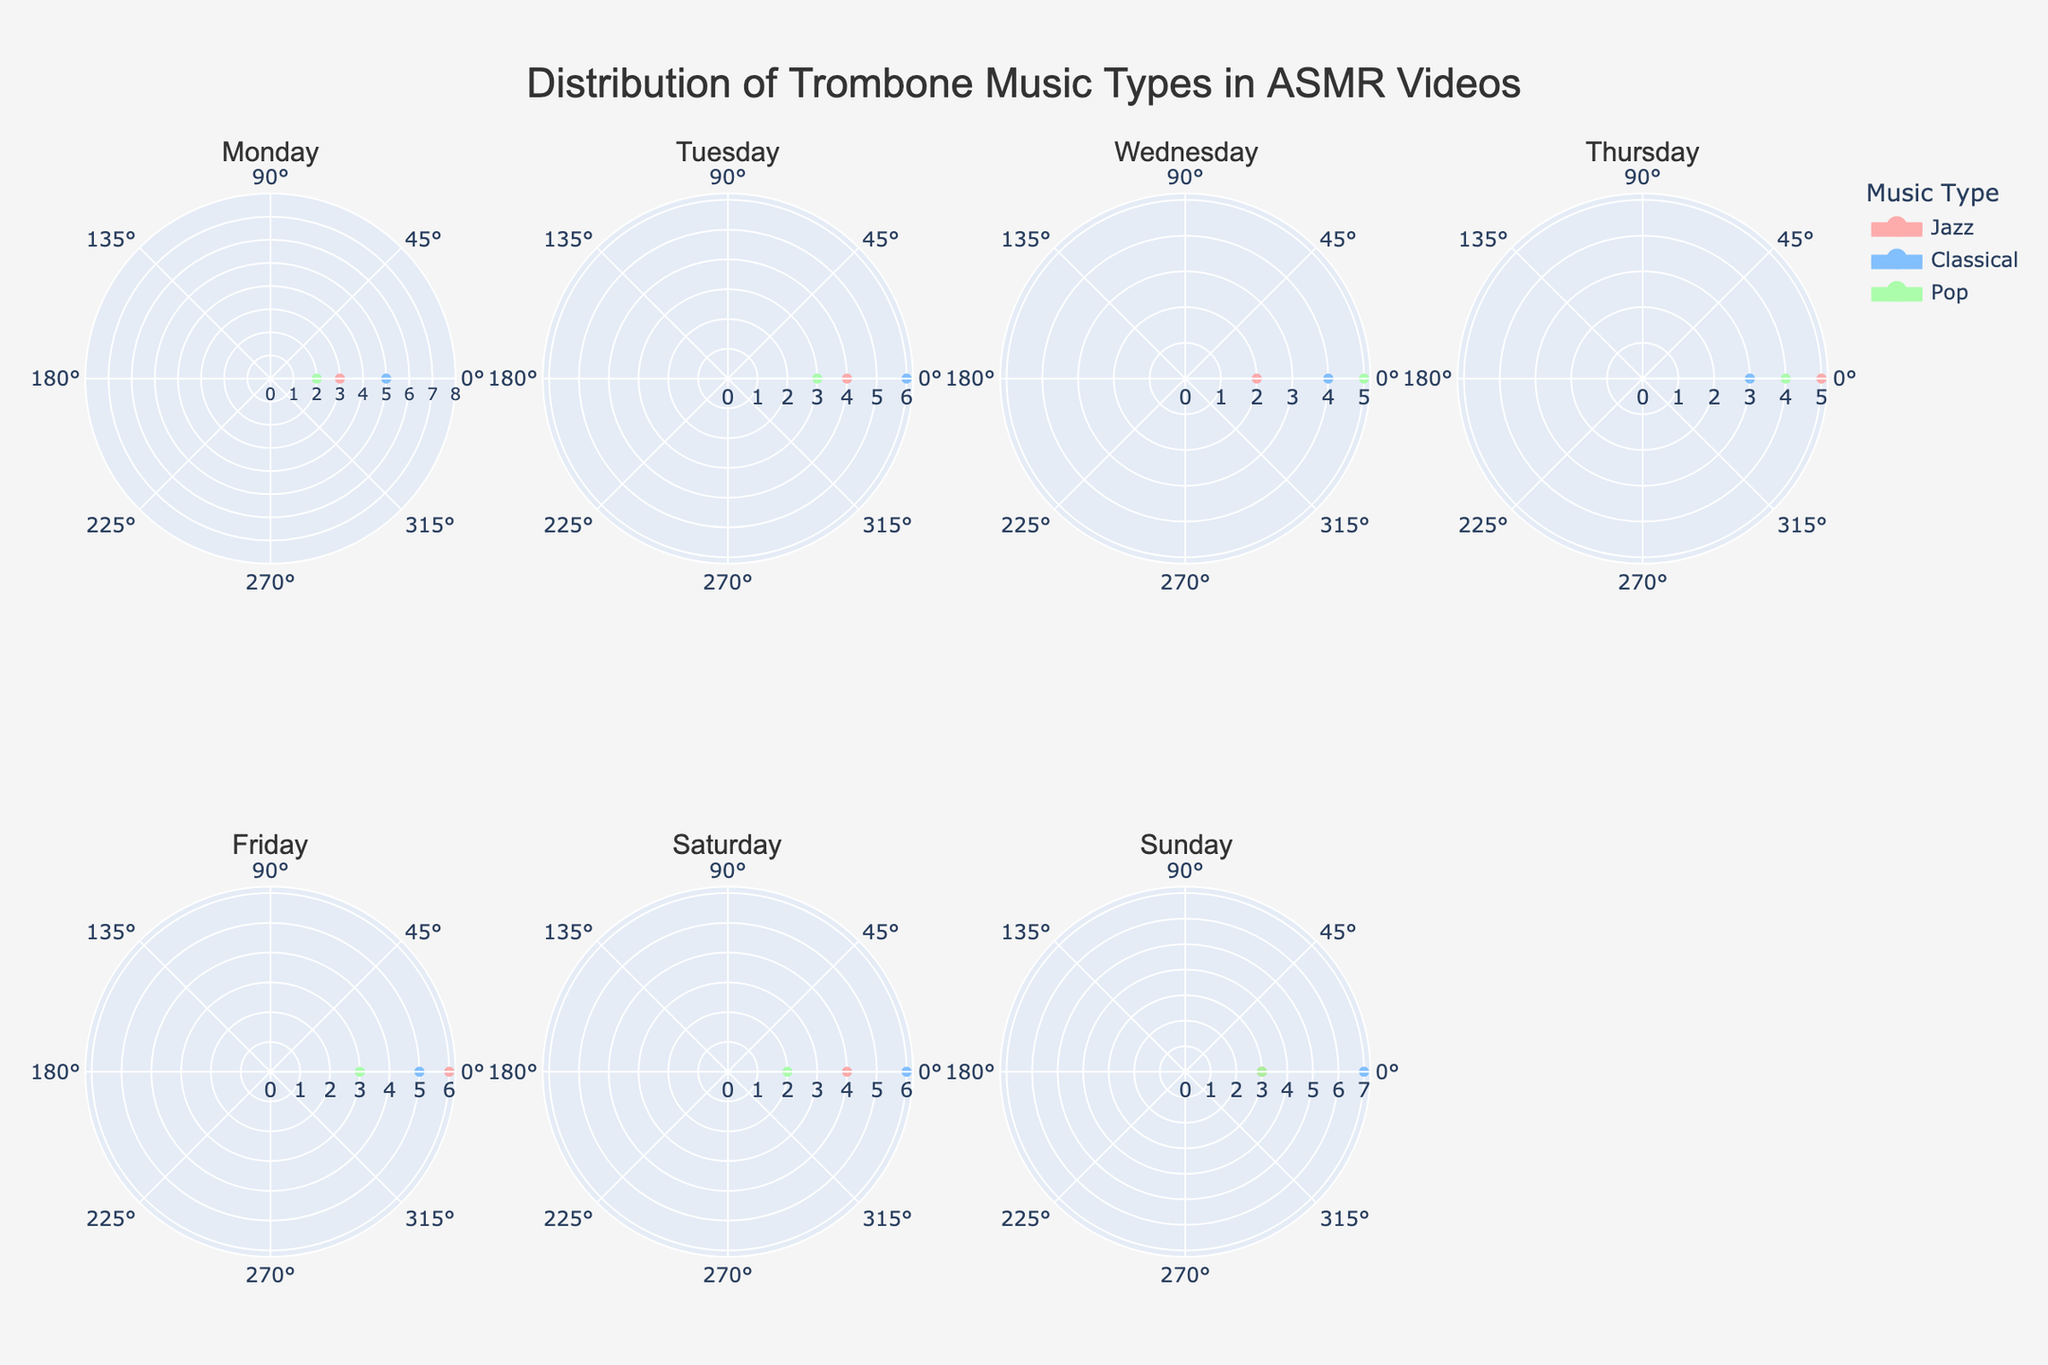How many music types are featured in ASMR videos on Wednesday? The rose charts for each day are organized by subplot titles, with music types displayed in different colors. For Wednesday, the subplot shows three colors representing Jazz, Classical, and Pop.
Answer: 3 On which day is Classical music most featured in ASMR videos? To find the day with the highest count for Classical music, look for the day when the count peaks among subplots. On Sunday, Classical music reaches a peak of 7.
Answer: Sunday What is the total count of Pop music in the whole week? Add the counts of Pop music from each day: 2 (Mon) + 3 (Tue) + 5 (Wed) + 4 (Thu) + 3 (Fri) + 2 (Sat) + 3 (Sun) = 22.
Answer: 22 Which day has the least variation in the count of different music types? Least variation means the counts for all music types are close to each other. On Thursday, the counts are 5 (Jazz), 3 (Classical), and 4 (Pop), showing small variation.
Answer: Thursday How many ASMR videos feature Jazz music on Friday? Refer to the Friday subplot and identify the count for Jazz music, which is represented by the relevant color. The count is 6.
Answer: 6 How does the distribution of Classical music on Tuesday compare to Saturday? Compare the counts: Tuesday has 6 for Classical music, while Saturday also has 6. They have the same count.
Answer: Equal/Same What is the average count of Jazz music throughout the week? Sum the Jazz counts for each day and divide by 7 (days): (3 + 4 + 2 + 5 + 6 + 4 + 3) / 7 = 27 / 7 ≈ 3.86.
Answer: 3.86 Is there a day where Pop music is more common than Classical music? Compare the counts for Classical and Pop for each day. On Wednesday, Pop (5) is more than Classical (4).
Answer: Wednesday Which day has the most uniform distribution of all three music types? Uniform distribution means all three types have similar counts. On Tuesday, the counts are 4 (Jazz), 6 (Classical), and 3 (Pop), which are relatively close compared to other days.
Answer: Tuesday What is the highest count recorded for any music type on any given day? Identify the highest peak across all subplots. The highest count recorded is 7 for Classical music on Sunday.
Answer: 7 